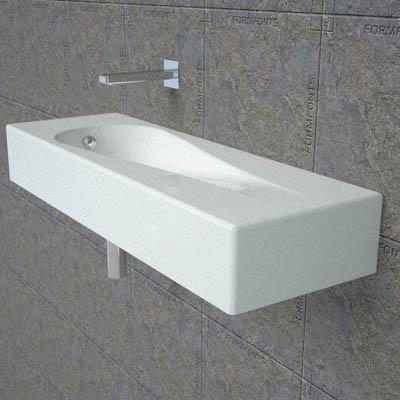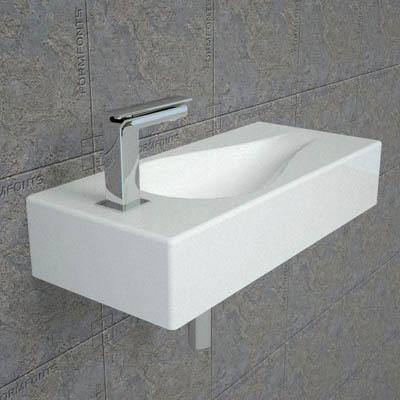The first image is the image on the left, the second image is the image on the right. Considering the images on both sides, is "In one image, two rectangular sinks with chrome faucet fixture are positioned side by side." valid? Answer yes or no. No. The first image is the image on the left, the second image is the image on the right. Evaluate the accuracy of this statement regarding the images: "The right image features two tear-drop carved white sinks positioned side-by-side.". Is it true? Answer yes or no. No. 